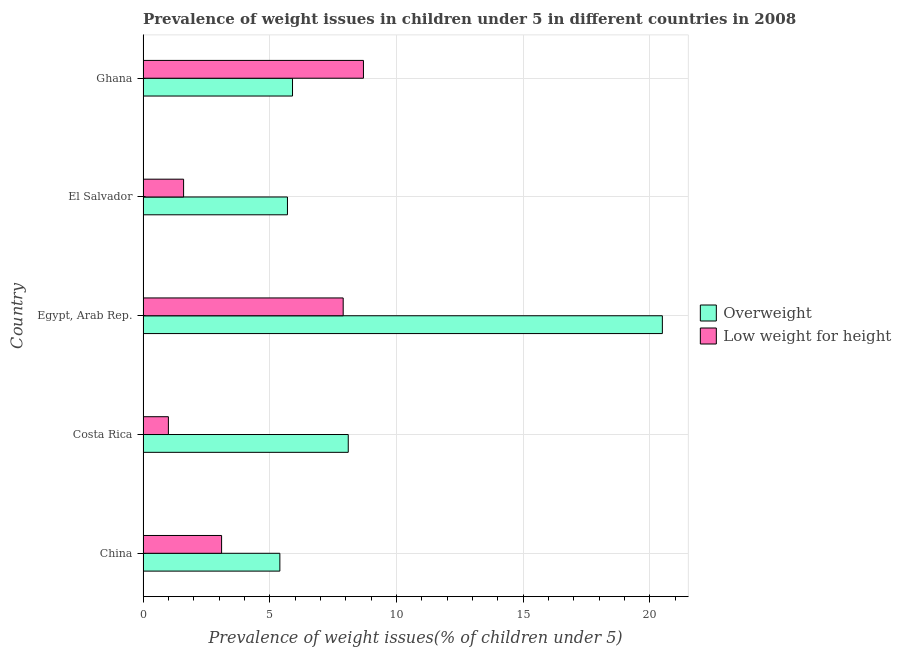How many groups of bars are there?
Provide a short and direct response. 5. Are the number of bars per tick equal to the number of legend labels?
Your response must be concise. Yes. How many bars are there on the 3rd tick from the top?
Ensure brevity in your answer.  2. What is the label of the 3rd group of bars from the top?
Provide a succinct answer. Egypt, Arab Rep. In how many cases, is the number of bars for a given country not equal to the number of legend labels?
Make the answer very short. 0. What is the percentage of overweight children in Ghana?
Your response must be concise. 5.9. Across all countries, what is the minimum percentage of overweight children?
Your answer should be very brief. 5.4. In which country was the percentage of overweight children maximum?
Your response must be concise. Egypt, Arab Rep. What is the total percentage of overweight children in the graph?
Give a very brief answer. 45.6. What is the difference between the percentage of underweight children in China and that in Costa Rica?
Ensure brevity in your answer.  2.1. What is the difference between the percentage of underweight children in Costa Rica and the percentage of overweight children in Ghana?
Provide a short and direct response. -4.9. What is the average percentage of overweight children per country?
Your answer should be compact. 9.12. What is the ratio of the percentage of underweight children in El Salvador to that in Ghana?
Offer a terse response. 0.18. What is the difference between the highest and the second highest percentage of overweight children?
Make the answer very short. 12.4. What is the difference between the highest and the lowest percentage of underweight children?
Give a very brief answer. 7.7. In how many countries, is the percentage of underweight children greater than the average percentage of underweight children taken over all countries?
Your answer should be compact. 2. Is the sum of the percentage of overweight children in Costa Rica and El Salvador greater than the maximum percentage of underweight children across all countries?
Offer a terse response. Yes. What does the 2nd bar from the top in China represents?
Your answer should be compact. Overweight. What does the 2nd bar from the bottom in Ghana represents?
Your response must be concise. Low weight for height. Are all the bars in the graph horizontal?
Provide a succinct answer. Yes. What is the difference between two consecutive major ticks on the X-axis?
Provide a succinct answer. 5. Does the graph contain any zero values?
Keep it short and to the point. No. How many legend labels are there?
Ensure brevity in your answer.  2. How are the legend labels stacked?
Provide a short and direct response. Vertical. What is the title of the graph?
Your answer should be compact. Prevalence of weight issues in children under 5 in different countries in 2008. Does "Register a business" appear as one of the legend labels in the graph?
Offer a very short reply. No. What is the label or title of the X-axis?
Provide a short and direct response. Prevalence of weight issues(% of children under 5). What is the Prevalence of weight issues(% of children under 5) in Overweight in China?
Your response must be concise. 5.4. What is the Prevalence of weight issues(% of children under 5) in Low weight for height in China?
Your response must be concise. 3.1. What is the Prevalence of weight issues(% of children under 5) of Overweight in Costa Rica?
Your answer should be compact. 8.1. What is the Prevalence of weight issues(% of children under 5) in Overweight in Egypt, Arab Rep.?
Your response must be concise. 20.5. What is the Prevalence of weight issues(% of children under 5) in Low weight for height in Egypt, Arab Rep.?
Provide a short and direct response. 7.9. What is the Prevalence of weight issues(% of children under 5) in Overweight in El Salvador?
Ensure brevity in your answer.  5.7. What is the Prevalence of weight issues(% of children under 5) in Low weight for height in El Salvador?
Your answer should be compact. 1.6. What is the Prevalence of weight issues(% of children under 5) of Overweight in Ghana?
Your answer should be very brief. 5.9. What is the Prevalence of weight issues(% of children under 5) in Low weight for height in Ghana?
Offer a very short reply. 8.7. Across all countries, what is the maximum Prevalence of weight issues(% of children under 5) of Low weight for height?
Offer a terse response. 8.7. Across all countries, what is the minimum Prevalence of weight issues(% of children under 5) of Overweight?
Your answer should be very brief. 5.4. Across all countries, what is the minimum Prevalence of weight issues(% of children under 5) in Low weight for height?
Your answer should be very brief. 1. What is the total Prevalence of weight issues(% of children under 5) in Overweight in the graph?
Offer a terse response. 45.6. What is the total Prevalence of weight issues(% of children under 5) in Low weight for height in the graph?
Provide a succinct answer. 22.3. What is the difference between the Prevalence of weight issues(% of children under 5) in Overweight in China and that in Costa Rica?
Your answer should be very brief. -2.7. What is the difference between the Prevalence of weight issues(% of children under 5) in Overweight in China and that in Egypt, Arab Rep.?
Offer a very short reply. -15.1. What is the difference between the Prevalence of weight issues(% of children under 5) in Overweight in Costa Rica and that in Egypt, Arab Rep.?
Your answer should be compact. -12.4. What is the difference between the Prevalence of weight issues(% of children under 5) in Low weight for height in Costa Rica and that in Egypt, Arab Rep.?
Keep it short and to the point. -6.9. What is the difference between the Prevalence of weight issues(% of children under 5) of Overweight in Costa Rica and that in El Salvador?
Your response must be concise. 2.4. What is the difference between the Prevalence of weight issues(% of children under 5) in Low weight for height in Costa Rica and that in Ghana?
Your response must be concise. -7.7. What is the difference between the Prevalence of weight issues(% of children under 5) in Overweight in Egypt, Arab Rep. and that in Ghana?
Give a very brief answer. 14.6. What is the difference between the Prevalence of weight issues(% of children under 5) of Overweight in El Salvador and that in Ghana?
Your response must be concise. -0.2. What is the difference between the Prevalence of weight issues(% of children under 5) in Overweight in China and the Prevalence of weight issues(% of children under 5) in Low weight for height in Costa Rica?
Your answer should be compact. 4.4. What is the difference between the Prevalence of weight issues(% of children under 5) in Overweight in China and the Prevalence of weight issues(% of children under 5) in Low weight for height in Ghana?
Provide a short and direct response. -3.3. What is the difference between the Prevalence of weight issues(% of children under 5) of Overweight in Costa Rica and the Prevalence of weight issues(% of children under 5) of Low weight for height in Egypt, Arab Rep.?
Keep it short and to the point. 0.2. What is the difference between the Prevalence of weight issues(% of children under 5) of Overweight in Costa Rica and the Prevalence of weight issues(% of children under 5) of Low weight for height in Ghana?
Your response must be concise. -0.6. What is the difference between the Prevalence of weight issues(% of children under 5) in Overweight in Egypt, Arab Rep. and the Prevalence of weight issues(% of children under 5) in Low weight for height in El Salvador?
Make the answer very short. 18.9. What is the difference between the Prevalence of weight issues(% of children under 5) of Overweight in Egypt, Arab Rep. and the Prevalence of weight issues(% of children under 5) of Low weight for height in Ghana?
Keep it short and to the point. 11.8. What is the difference between the Prevalence of weight issues(% of children under 5) of Overweight in El Salvador and the Prevalence of weight issues(% of children under 5) of Low weight for height in Ghana?
Your answer should be compact. -3. What is the average Prevalence of weight issues(% of children under 5) in Overweight per country?
Keep it short and to the point. 9.12. What is the average Prevalence of weight issues(% of children under 5) in Low weight for height per country?
Your answer should be compact. 4.46. What is the difference between the Prevalence of weight issues(% of children under 5) of Overweight and Prevalence of weight issues(% of children under 5) of Low weight for height in Costa Rica?
Offer a terse response. 7.1. What is the difference between the Prevalence of weight issues(% of children under 5) of Overweight and Prevalence of weight issues(% of children under 5) of Low weight for height in Egypt, Arab Rep.?
Ensure brevity in your answer.  12.6. What is the ratio of the Prevalence of weight issues(% of children under 5) in Overweight in China to that in Costa Rica?
Your response must be concise. 0.67. What is the ratio of the Prevalence of weight issues(% of children under 5) of Overweight in China to that in Egypt, Arab Rep.?
Make the answer very short. 0.26. What is the ratio of the Prevalence of weight issues(% of children under 5) of Low weight for height in China to that in Egypt, Arab Rep.?
Give a very brief answer. 0.39. What is the ratio of the Prevalence of weight issues(% of children under 5) of Overweight in China to that in El Salvador?
Ensure brevity in your answer.  0.95. What is the ratio of the Prevalence of weight issues(% of children under 5) of Low weight for height in China to that in El Salvador?
Give a very brief answer. 1.94. What is the ratio of the Prevalence of weight issues(% of children under 5) of Overweight in China to that in Ghana?
Your answer should be compact. 0.92. What is the ratio of the Prevalence of weight issues(% of children under 5) in Low weight for height in China to that in Ghana?
Ensure brevity in your answer.  0.36. What is the ratio of the Prevalence of weight issues(% of children under 5) of Overweight in Costa Rica to that in Egypt, Arab Rep.?
Your response must be concise. 0.4. What is the ratio of the Prevalence of weight issues(% of children under 5) of Low weight for height in Costa Rica to that in Egypt, Arab Rep.?
Make the answer very short. 0.13. What is the ratio of the Prevalence of weight issues(% of children under 5) of Overweight in Costa Rica to that in El Salvador?
Ensure brevity in your answer.  1.42. What is the ratio of the Prevalence of weight issues(% of children under 5) in Low weight for height in Costa Rica to that in El Salvador?
Offer a very short reply. 0.62. What is the ratio of the Prevalence of weight issues(% of children under 5) of Overweight in Costa Rica to that in Ghana?
Provide a succinct answer. 1.37. What is the ratio of the Prevalence of weight issues(% of children under 5) in Low weight for height in Costa Rica to that in Ghana?
Keep it short and to the point. 0.11. What is the ratio of the Prevalence of weight issues(% of children under 5) in Overweight in Egypt, Arab Rep. to that in El Salvador?
Keep it short and to the point. 3.6. What is the ratio of the Prevalence of weight issues(% of children under 5) of Low weight for height in Egypt, Arab Rep. to that in El Salvador?
Provide a succinct answer. 4.94. What is the ratio of the Prevalence of weight issues(% of children under 5) in Overweight in Egypt, Arab Rep. to that in Ghana?
Provide a succinct answer. 3.47. What is the ratio of the Prevalence of weight issues(% of children under 5) in Low weight for height in Egypt, Arab Rep. to that in Ghana?
Ensure brevity in your answer.  0.91. What is the ratio of the Prevalence of weight issues(% of children under 5) of Overweight in El Salvador to that in Ghana?
Keep it short and to the point. 0.97. What is the ratio of the Prevalence of weight issues(% of children under 5) of Low weight for height in El Salvador to that in Ghana?
Provide a short and direct response. 0.18. What is the difference between the highest and the second highest Prevalence of weight issues(% of children under 5) of Overweight?
Your answer should be very brief. 12.4. What is the difference between the highest and the second highest Prevalence of weight issues(% of children under 5) in Low weight for height?
Keep it short and to the point. 0.8. What is the difference between the highest and the lowest Prevalence of weight issues(% of children under 5) of Low weight for height?
Your response must be concise. 7.7. 